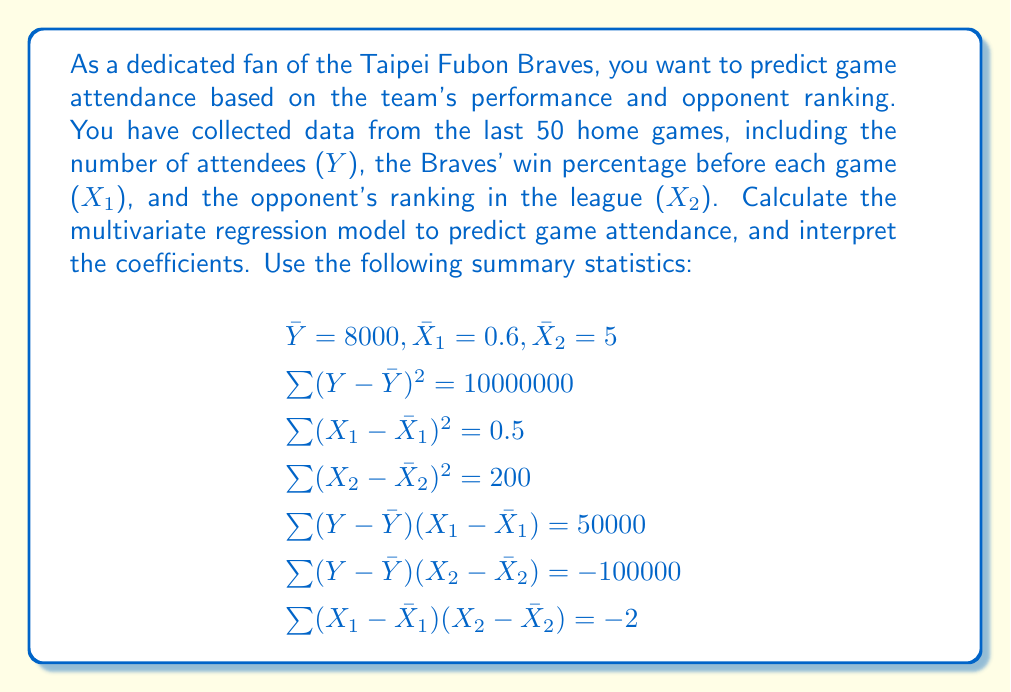What is the answer to this math problem? To calculate the multivariate regression model, we need to find the coefficients β₁ and β₂ in the equation:

$$Y = \beta_0 + \beta_1 X_1 + \beta_2 X_2 + \epsilon$$

We'll use the normal equations to solve for β₁ and β₂:

$$\begin{bmatrix}
\sum (X_1 - \bar{X}_1)^2 & \sum (X_1 - \bar{X}_1)(X_2 - \bar{X}_2) \\
\sum (X_1 - \bar{X}_1)(X_2 - \bar{X}_2) & \sum (X_2 - \bar{X}_2)^2
\end{bmatrix}
\begin{bmatrix}
\beta_1 \\
\beta_2
\end{bmatrix} =
\begin{bmatrix}
\sum (Y - \bar{Y})(X_1 - \bar{X}_1) \\
\sum (Y - \bar{Y})(X_2 - \bar{X}_2)
\end{bmatrix}$$

Substituting the given values:

$$\begin{bmatrix}
0.5 & -2 \\
-2 & 200
\end{bmatrix}
\begin{bmatrix}
\beta_1 \\
\beta_2
\end{bmatrix} =
\begin{bmatrix}
50000 \\
-100000
\end{bmatrix}$$

Solving this system of equations:

$$\beta_1 = 100000$$
$$\beta_2 = -500$$

To find β₀, we use the equation:

$$\beta_0 = \bar{Y} - \beta_1 \bar{X}_1 - \beta_2 \bar{X}_2$$

Substituting the values:

$$\beta_0 = 8000 - 100000(0.6) - (-500)(5) = -52500$$

The final regression equation is:

$$Y = -52500 + 100000X_1 - 500X_2$$

Interpreting the coefficients:
- β₁ = 100000: For every 1 unit increase in the Braves' win percentage, the predicted attendance increases by 100,000, holding the opponent's ranking constant.
- β₂ = -500: For every 1 rank increase in the opponent's ranking (lower rank), the predicted attendance decreases by 500, holding the Braves' win percentage constant.
- β₀ = -52500: The predicted attendance when both the Braves' win percentage and opponent's ranking are 0 (which is not meaningful in this context).
Answer: The multivariate regression model for predicting game attendance is:

$$Y = -52500 + 100000X_1 - 500X_2$$

Where:
- Y is the predicted game attendance
- X₁ is the Taipei Fubon Braves' win percentage
- X₂ is the opponent's ranking in the league 